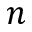Convert formula to latex. <formula><loc_0><loc_0><loc_500><loc_500>n</formula> 